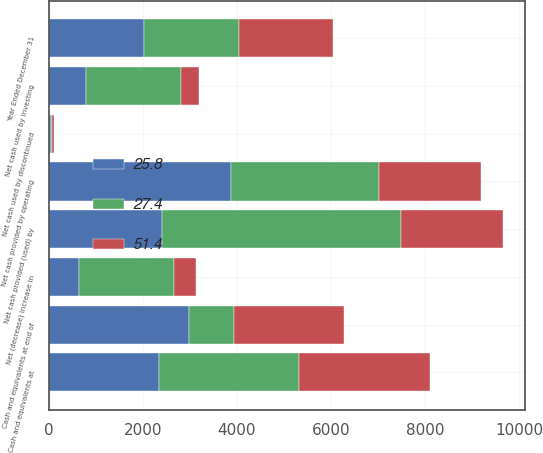Convert chart to OTSL. <chart><loc_0><loc_0><loc_500><loc_500><stacked_bar_chart><ecel><fcel>Year Ended December 31<fcel>Net cash provided by operating<fcel>Net cash used by investing<fcel>Net cash provided (used) by<fcel>Net cash used by discontinued<fcel>Net (decrease) increase in<fcel>Cash and equivalents at<fcel>Cash and equivalents at end of<nl><fcel>27.4<fcel>2018<fcel>3148<fcel>2020<fcel>5086<fcel>20<fcel>2020<fcel>2983<fcel>963<nl><fcel>25.8<fcel>2017<fcel>3876<fcel>788<fcel>2399<fcel>40<fcel>649<fcel>2334<fcel>2983<nl><fcel>51.4<fcel>2016<fcel>2163<fcel>391<fcel>2169<fcel>54<fcel>451<fcel>2785<fcel>2334<nl></chart> 